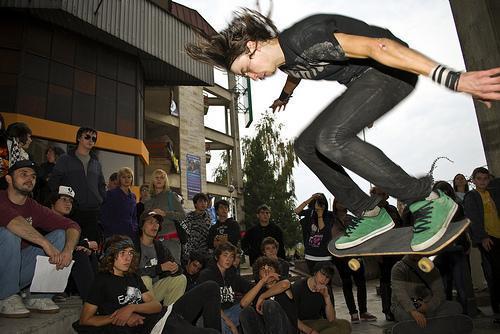How many skateboards can be seen in the picture?
Give a very brief answer. 2. 